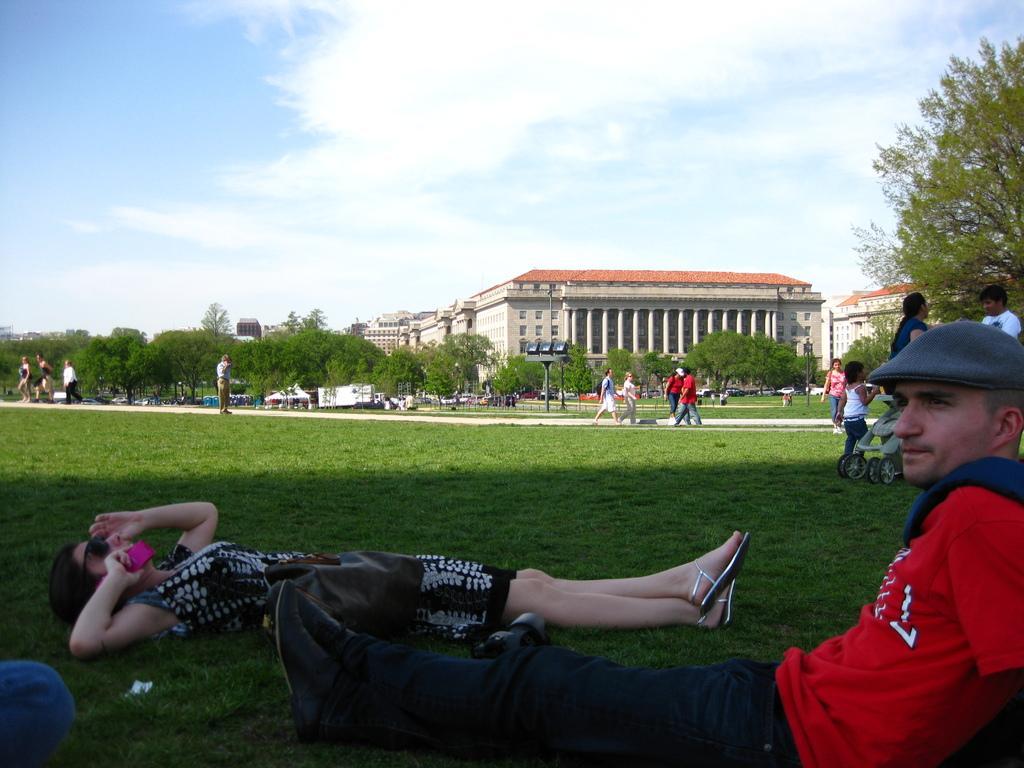Can you describe this image briefly? In this image in the foreground there are two persons one person is sitting and one person is laying and she is holding a mobile. At the bottom there is grass and in the background there are a group of people who are walking, and also we could see some trees, buildings and some poles. At the top of the image there is sky. 